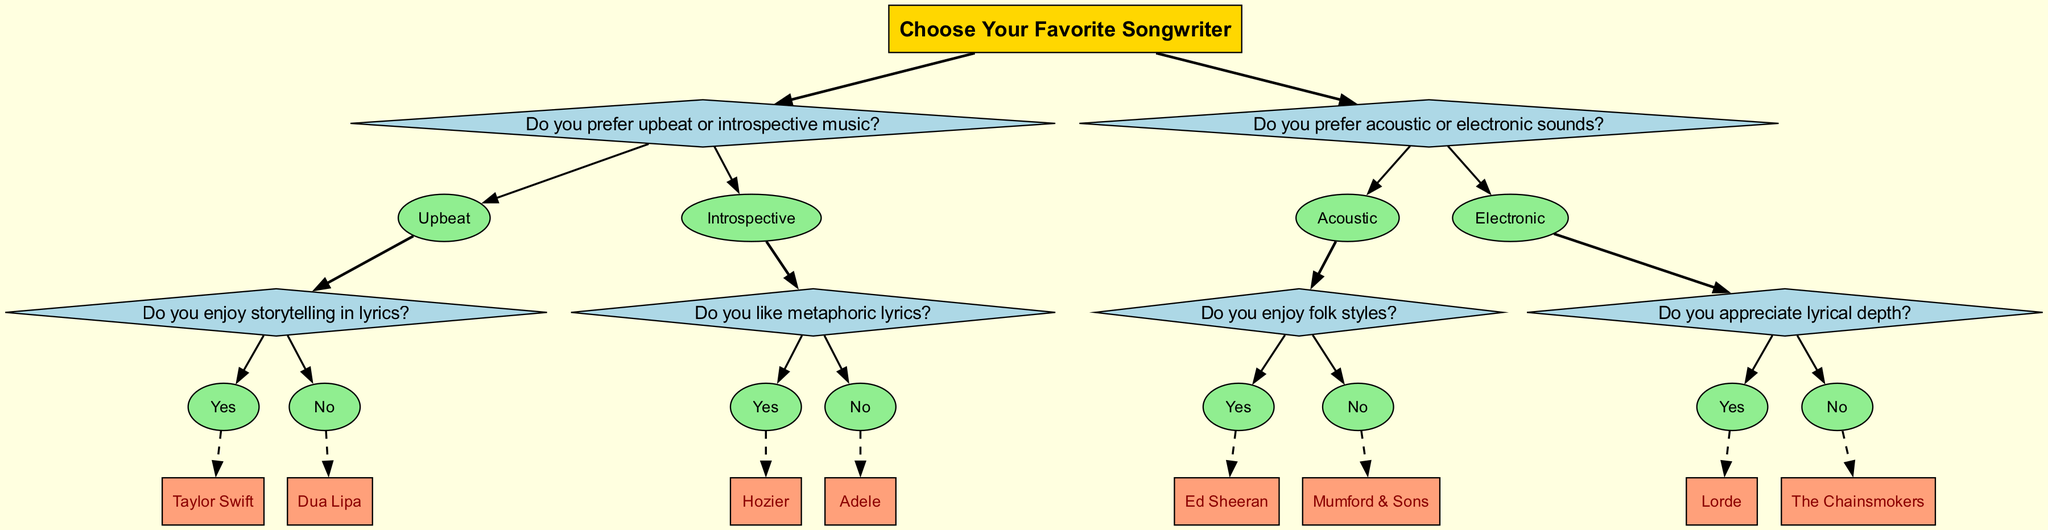What is the first question you encounter in the diagram? The first question presented at the root of the tree is "Do you prefer upbeat or introspective music?" This is the starting point for the decision-making process in the diagram.
Answer: Do you prefer upbeat or introspective music? Which songwriter is associated with "Yes" to storytelling in lyrics? If you follow the path where the answer to the question "Do you enjoy storytelling in lyrics?" is "Yes," the corresponding songwriter at the end of that branch is Taylor Swift.
Answer: Taylor Swift How many songwriters are represented in the diagram? To determine the total number of songwriters, we can count the songwriter nodes at the end of the branches. There are a total of six songwriters represented: Taylor Swift, Dua Lipa, Hozier, Adele, Ed Sheeran, Mumford & Sons, Lorde, and The Chainsmokers. Thus, there are eight songwriters in total.
Answer: Eight What is the answer if someone prefers acoustic sounds and enjoys folk styles? By following the branches for someone who prefers "Acoustic" sounds and then further selects "Yes" to enjoying folk styles, the corresponding songwriter is Ed Sheeran.
Answer: Ed Sheeran Which songwriter is associated with "No" to liking metaphoric lyrics? Tracing the path where the answer to the question "Do you like metaphoric lyrics?" is "No," the resulting songwriter is Adele, who follows this line of questions.
Answer: Adele What is the last potential answer in the electronic category? To find the last songwriter in the electronic category, follow the path for "Electronic" sounds, then to "No" for appreciating lyrical depth. The corresponding songwriter here is The Chainsmokers, making it the last option within that category.
Answer: The Chainsmokers What is the relationship between Taylor Swift and the answer to preferring upbeat music? Taylor Swift is at the end of the branch that follows answering "Yes" to enjoying storytelling in lyrics provided the preference of "Upbeat" music was selected. This establishes Taylor Swift as the associated songwriter for this combination.
Answer: Associated songwriter What type of music does Hozier represent in this diagram? Hozier is located in the branch that follows the answers "Introspective" music and "Yes" for liking metaphoric lyrics. This suggests that Hozier represents introspective music with a focus on metaphoric themes.
Answer: Introspective music with metaphoric themes 